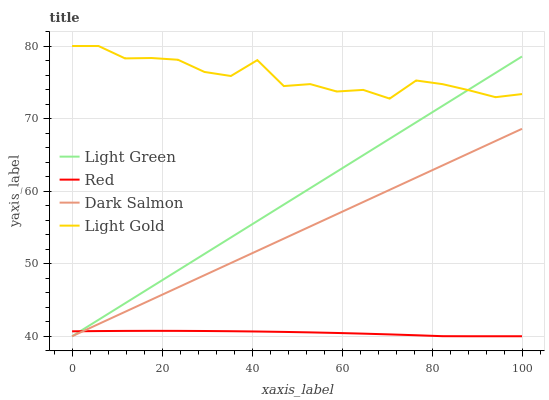Does Red have the minimum area under the curve?
Answer yes or no. Yes. Does Light Gold have the maximum area under the curve?
Answer yes or no. Yes. Does Light Green have the minimum area under the curve?
Answer yes or no. No. Does Light Green have the maximum area under the curve?
Answer yes or no. No. Is Light Green the smoothest?
Answer yes or no. Yes. Is Light Gold the roughest?
Answer yes or no. Yes. Is Red the smoothest?
Answer yes or no. No. Is Red the roughest?
Answer yes or no. No. Does Red have the lowest value?
Answer yes or no. Yes. Does Light Gold have the highest value?
Answer yes or no. Yes. Does Light Green have the highest value?
Answer yes or no. No. Is Red less than Light Gold?
Answer yes or no. Yes. Is Light Gold greater than Red?
Answer yes or no. Yes. Does Light Green intersect Dark Salmon?
Answer yes or no. Yes. Is Light Green less than Dark Salmon?
Answer yes or no. No. Is Light Green greater than Dark Salmon?
Answer yes or no. No. Does Red intersect Light Gold?
Answer yes or no. No. 